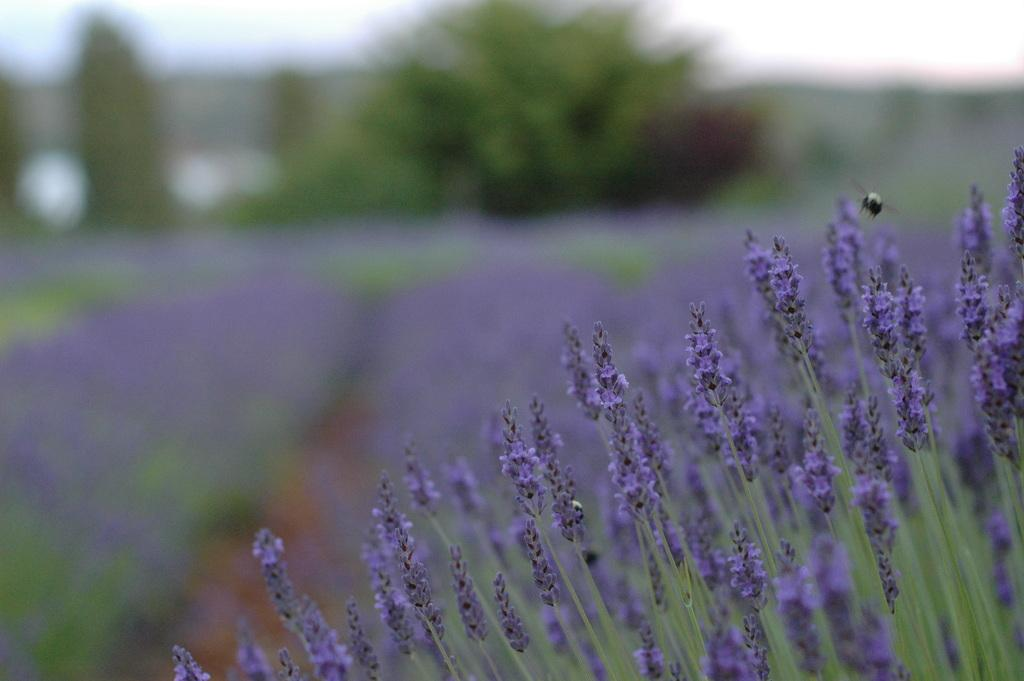What type of flowers can be seen on the plants in the image? The plants in the image have violet color flowers. What other types of vegetation are visible in the image? There are trees visible at the top of the image. What is visible in the background of the image? The sky is visible at the top of the image. How does the porter feel about the punishment in the image? There is no porter or punishment present in the image; it features plants with violet color flowers and trees. 